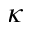Convert formula to latex. <formula><loc_0><loc_0><loc_500><loc_500>\kappa</formula> 